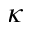Convert formula to latex. <formula><loc_0><loc_0><loc_500><loc_500>\kappa</formula> 